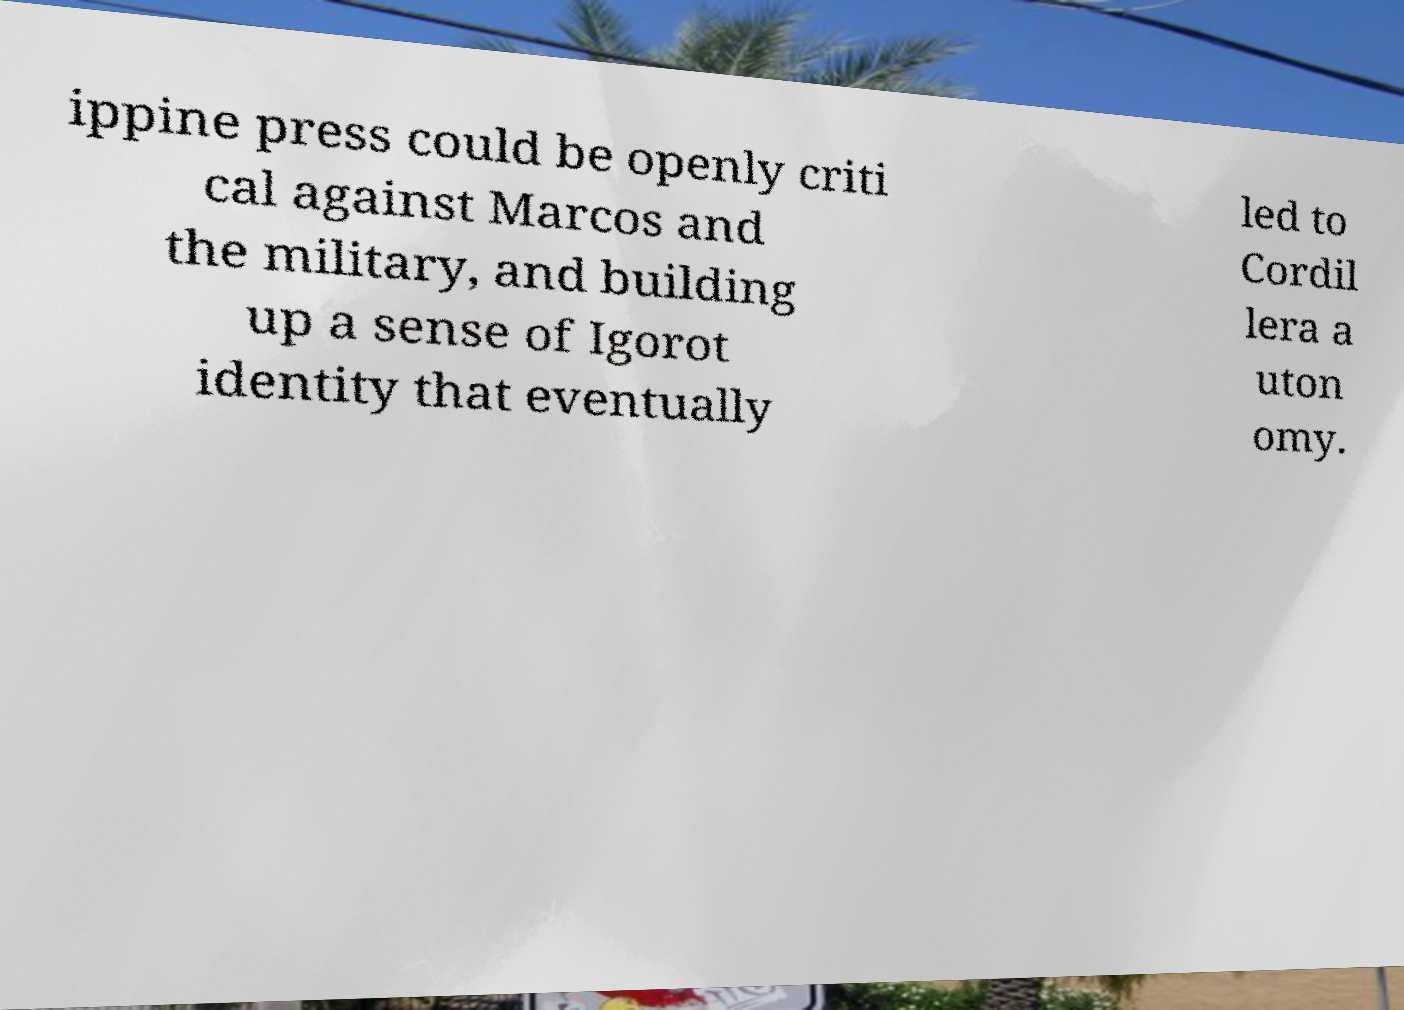Can you accurately transcribe the text from the provided image for me? ippine press could be openly criti cal against Marcos and the military, and building up a sense of Igorot identity that eventually led to Cordil lera a uton omy. 